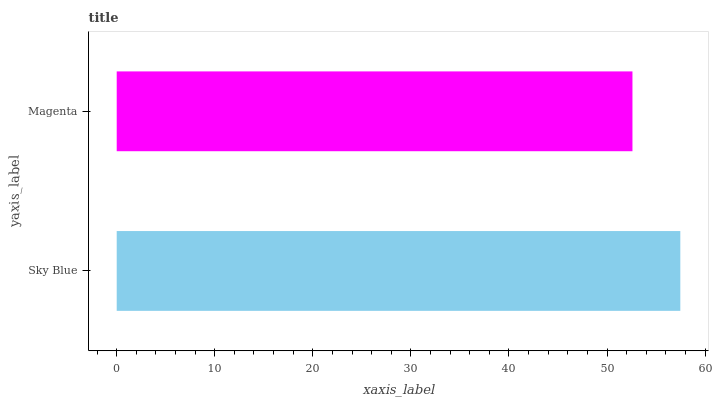Is Magenta the minimum?
Answer yes or no. Yes. Is Sky Blue the maximum?
Answer yes or no. Yes. Is Magenta the maximum?
Answer yes or no. No. Is Sky Blue greater than Magenta?
Answer yes or no. Yes. Is Magenta less than Sky Blue?
Answer yes or no. Yes. Is Magenta greater than Sky Blue?
Answer yes or no. No. Is Sky Blue less than Magenta?
Answer yes or no. No. Is Sky Blue the high median?
Answer yes or no. Yes. Is Magenta the low median?
Answer yes or no. Yes. Is Magenta the high median?
Answer yes or no. No. Is Sky Blue the low median?
Answer yes or no. No. 